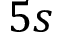<formula> <loc_0><loc_0><loc_500><loc_500>5 s</formula> 